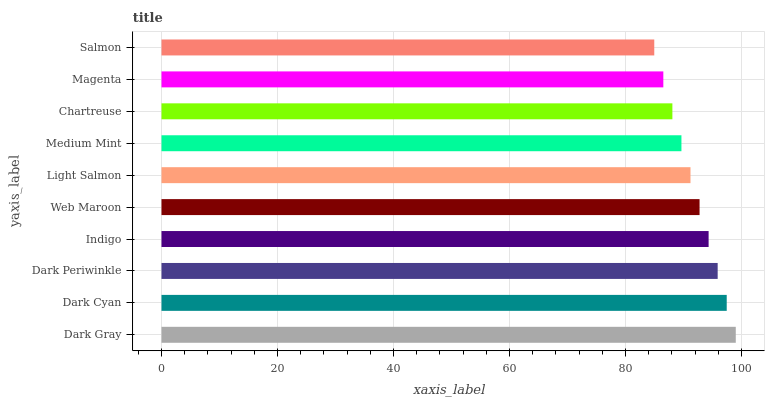Is Salmon the minimum?
Answer yes or no. Yes. Is Dark Gray the maximum?
Answer yes or no. Yes. Is Dark Cyan the minimum?
Answer yes or no. No. Is Dark Cyan the maximum?
Answer yes or no. No. Is Dark Gray greater than Dark Cyan?
Answer yes or no. Yes. Is Dark Cyan less than Dark Gray?
Answer yes or no. Yes. Is Dark Cyan greater than Dark Gray?
Answer yes or no. No. Is Dark Gray less than Dark Cyan?
Answer yes or no. No. Is Web Maroon the high median?
Answer yes or no. Yes. Is Light Salmon the low median?
Answer yes or no. Yes. Is Dark Gray the high median?
Answer yes or no. No. Is Dark Periwinkle the low median?
Answer yes or no. No. 